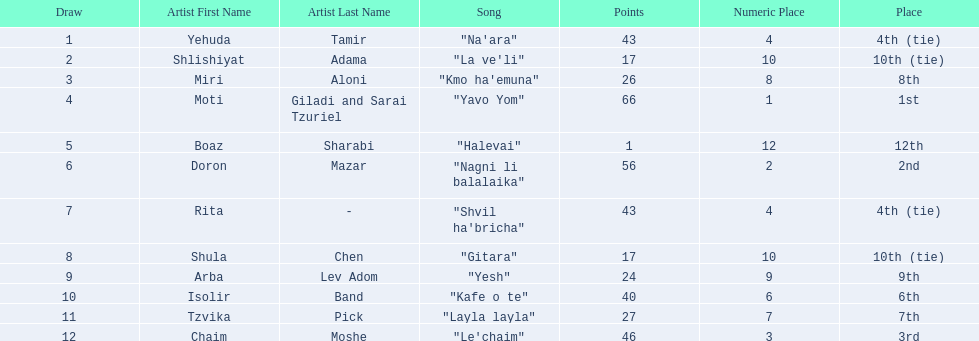Who were all the artists at the contest? Yehuda Tamir, Shlishiyat Adama, Miri Aloni, Moti Giladi and Sarai Tzuriel, Boaz Sharabi, Doron Mazar, Rita, Shula Chen, Arba Lev Adom, Isolir Band, Tzvika Pick, Chaim Moshe. What were their point totals? 43, 17, 26, 66, 1, 56, 43, 17, 24, 40, 27, 46. Of these, which is the least amount of points? 1. Which artists received this point total? Boaz Sharabi. 